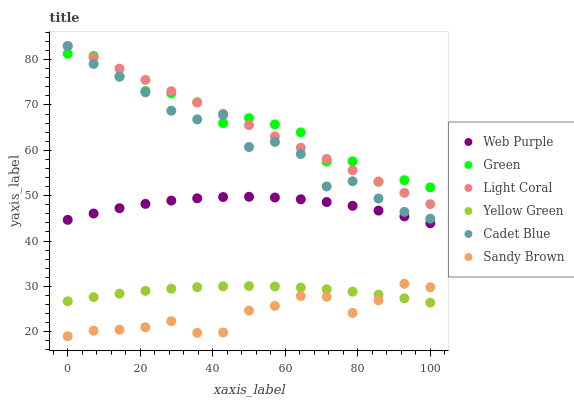Does Sandy Brown have the minimum area under the curve?
Answer yes or no. Yes. Does Green have the maximum area under the curve?
Answer yes or no. Yes. Does Yellow Green have the minimum area under the curve?
Answer yes or no. No. Does Yellow Green have the maximum area under the curve?
Answer yes or no. No. Is Light Coral the smoothest?
Answer yes or no. Yes. Is Cadet Blue the roughest?
Answer yes or no. Yes. Is Yellow Green the smoothest?
Answer yes or no. No. Is Yellow Green the roughest?
Answer yes or no. No. Does Sandy Brown have the lowest value?
Answer yes or no. Yes. Does Yellow Green have the lowest value?
Answer yes or no. No. Does Light Coral have the highest value?
Answer yes or no. Yes. Does Yellow Green have the highest value?
Answer yes or no. No. Is Sandy Brown less than Light Coral?
Answer yes or no. Yes. Is Green greater than Sandy Brown?
Answer yes or no. Yes. Does Light Coral intersect Green?
Answer yes or no. Yes. Is Light Coral less than Green?
Answer yes or no. No. Is Light Coral greater than Green?
Answer yes or no. No. Does Sandy Brown intersect Light Coral?
Answer yes or no. No. 